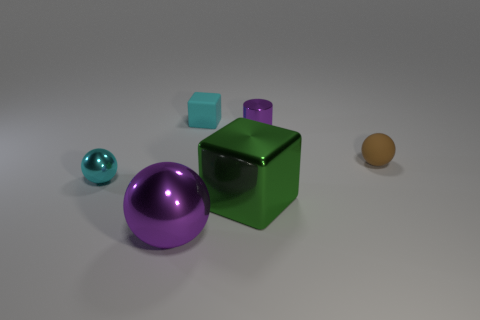Add 2 big gray rubber things. How many objects exist? 8 Subtract all cylinders. How many objects are left? 5 Subtract 0 brown blocks. How many objects are left? 6 Subtract all cyan metallic spheres. Subtract all large blocks. How many objects are left? 4 Add 6 tiny shiny things. How many tiny shiny things are left? 8 Add 2 tiny brown metallic cubes. How many tiny brown metallic cubes exist? 2 